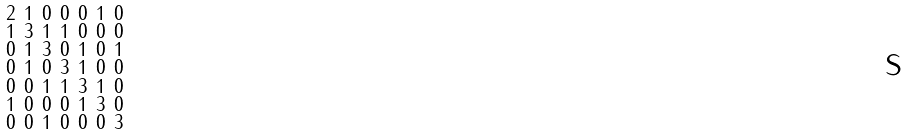<formula> <loc_0><loc_0><loc_500><loc_500>\begin{smallmatrix} 2 & 1 & 0 & 0 & 0 & 1 & 0 \\ 1 & 3 & 1 & 1 & 0 & 0 & 0 \\ 0 & 1 & 3 & 0 & 1 & 0 & 1 \\ 0 & 1 & 0 & 3 & 1 & 0 & 0 \\ 0 & 0 & 1 & 1 & 3 & 1 & 0 \\ 1 & 0 & 0 & 0 & 1 & 3 & 0 \\ 0 & 0 & 1 & 0 & 0 & 0 & 3 \end{smallmatrix}</formula> 